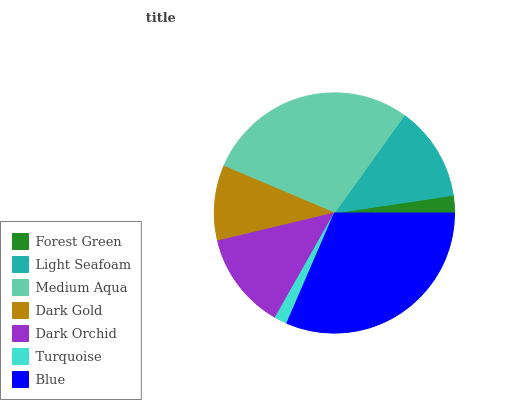Is Turquoise the minimum?
Answer yes or no. Yes. Is Blue the maximum?
Answer yes or no. Yes. Is Light Seafoam the minimum?
Answer yes or no. No. Is Light Seafoam the maximum?
Answer yes or no. No. Is Light Seafoam greater than Forest Green?
Answer yes or no. Yes. Is Forest Green less than Light Seafoam?
Answer yes or no. Yes. Is Forest Green greater than Light Seafoam?
Answer yes or no. No. Is Light Seafoam less than Forest Green?
Answer yes or no. No. Is Light Seafoam the high median?
Answer yes or no. Yes. Is Light Seafoam the low median?
Answer yes or no. Yes. Is Forest Green the high median?
Answer yes or no. No. Is Forest Green the low median?
Answer yes or no. No. 